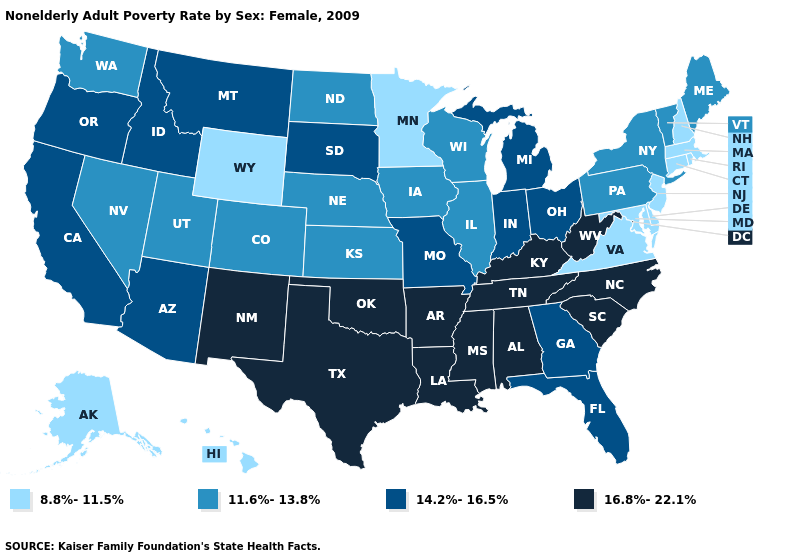Does the first symbol in the legend represent the smallest category?
Write a very short answer. Yes. How many symbols are there in the legend?
Answer briefly. 4. Name the states that have a value in the range 11.6%-13.8%?
Write a very short answer. Colorado, Illinois, Iowa, Kansas, Maine, Nebraska, Nevada, New York, North Dakota, Pennsylvania, Utah, Vermont, Washington, Wisconsin. Which states hav the highest value in the South?
Short answer required. Alabama, Arkansas, Kentucky, Louisiana, Mississippi, North Carolina, Oklahoma, South Carolina, Tennessee, Texas, West Virginia. What is the lowest value in the South?
Write a very short answer. 8.8%-11.5%. What is the lowest value in the USA?
Be succinct. 8.8%-11.5%. Does Delaware have the highest value in the South?
Short answer required. No. Does the first symbol in the legend represent the smallest category?
Short answer required. Yes. Name the states that have a value in the range 8.8%-11.5%?
Keep it brief. Alaska, Connecticut, Delaware, Hawaii, Maryland, Massachusetts, Minnesota, New Hampshire, New Jersey, Rhode Island, Virginia, Wyoming. Does Louisiana have the highest value in the USA?
Write a very short answer. Yes. Does Kansas have the lowest value in the MidWest?
Short answer required. No. What is the value of Virginia?
Keep it brief. 8.8%-11.5%. What is the value of Alabama?
Concise answer only. 16.8%-22.1%. What is the value of Massachusetts?
Answer briefly. 8.8%-11.5%. What is the value of New York?
Keep it brief. 11.6%-13.8%. 